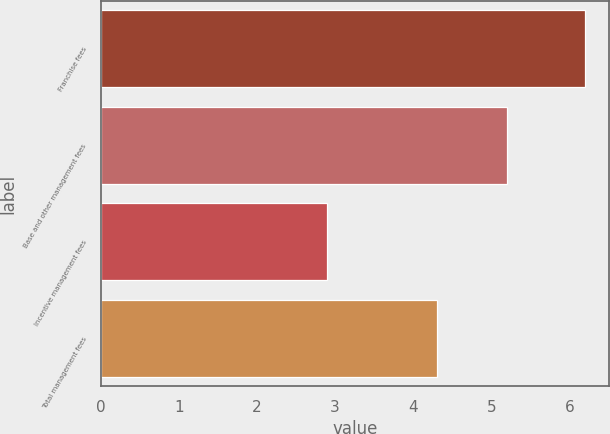Convert chart to OTSL. <chart><loc_0><loc_0><loc_500><loc_500><bar_chart><fcel>Franchise fees<fcel>Base and other management fees<fcel>Incentive management fees<fcel>Total management fees<nl><fcel>6.2<fcel>5.2<fcel>2.9<fcel>4.3<nl></chart> 